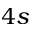<formula> <loc_0><loc_0><loc_500><loc_500>4 s</formula> 